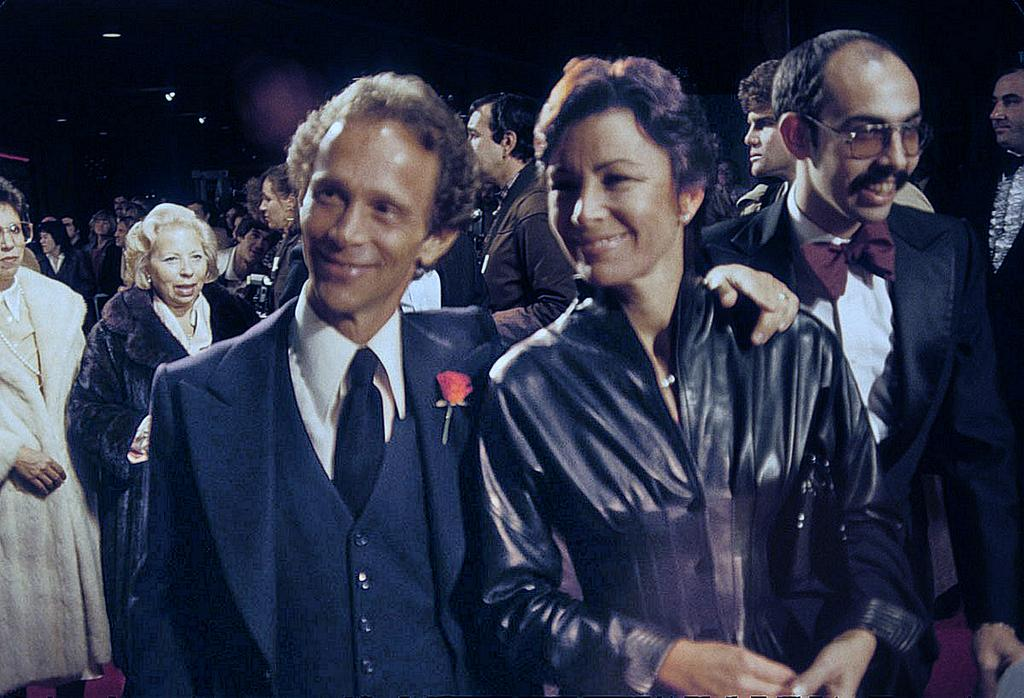How many people are in the front of the image? There are two people in the front of the image. What are the expressions on the faces of the two people? The two people are smiling. Who are the two people looking at? The two people are looking at someone. Can you describe the scene in the background of the image? There are many people standing in the background of the image. What rule is being enforced by the person on the bike in the image? There is no person on a bike in the image, nor is there any mention of a rule being enforced. 